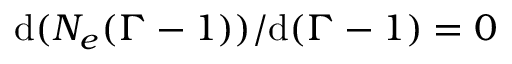Convert formula to latex. <formula><loc_0><loc_0><loc_500><loc_500>d ( N _ { e } ( \Gamma - 1 ) ) / d ( \Gamma - 1 ) = 0</formula> 